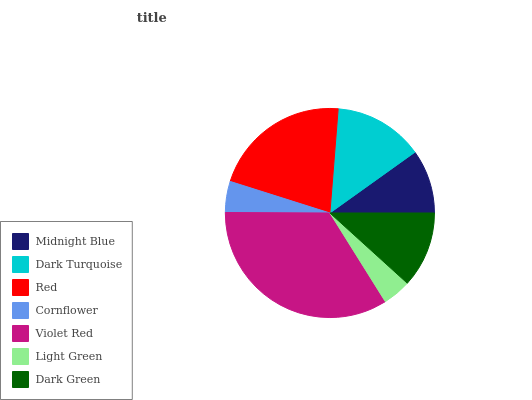Is Light Green the minimum?
Answer yes or no. Yes. Is Violet Red the maximum?
Answer yes or no. Yes. Is Dark Turquoise the minimum?
Answer yes or no. No. Is Dark Turquoise the maximum?
Answer yes or no. No. Is Dark Turquoise greater than Midnight Blue?
Answer yes or no. Yes. Is Midnight Blue less than Dark Turquoise?
Answer yes or no. Yes. Is Midnight Blue greater than Dark Turquoise?
Answer yes or no. No. Is Dark Turquoise less than Midnight Blue?
Answer yes or no. No. Is Dark Green the high median?
Answer yes or no. Yes. Is Dark Green the low median?
Answer yes or no. Yes. Is Cornflower the high median?
Answer yes or no. No. Is Midnight Blue the low median?
Answer yes or no. No. 